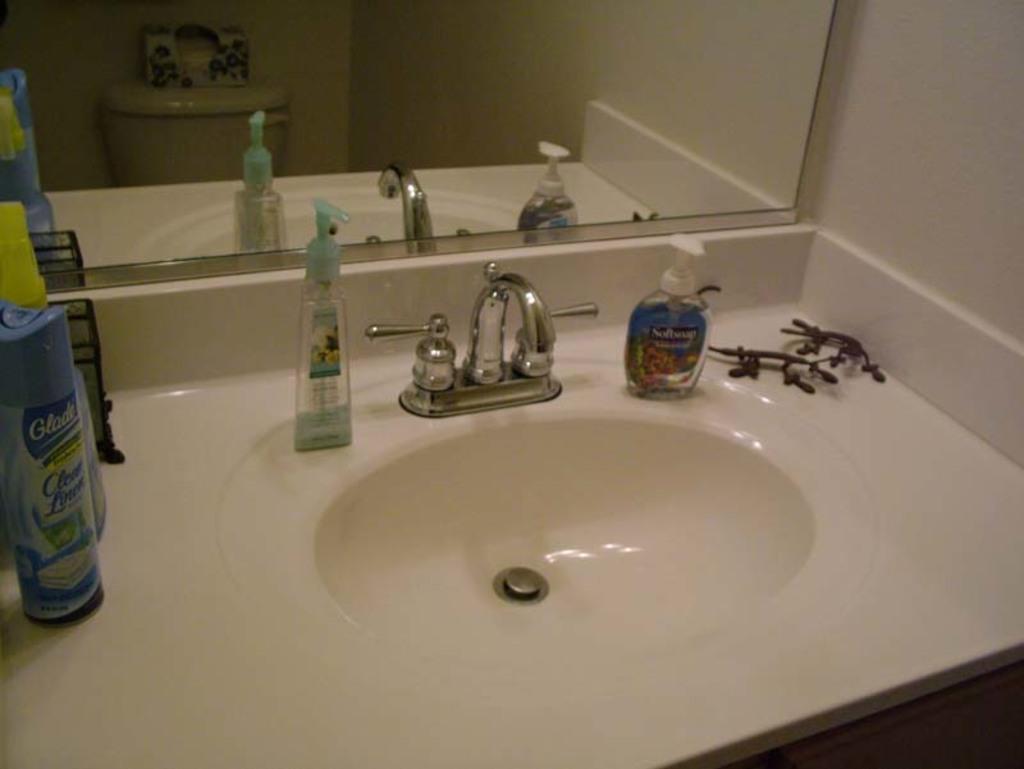In one or two sentences, can you explain what this image depicts? In this image, we can see bottles and some objects on the sink and in the background, there is a mirror and a wall. 